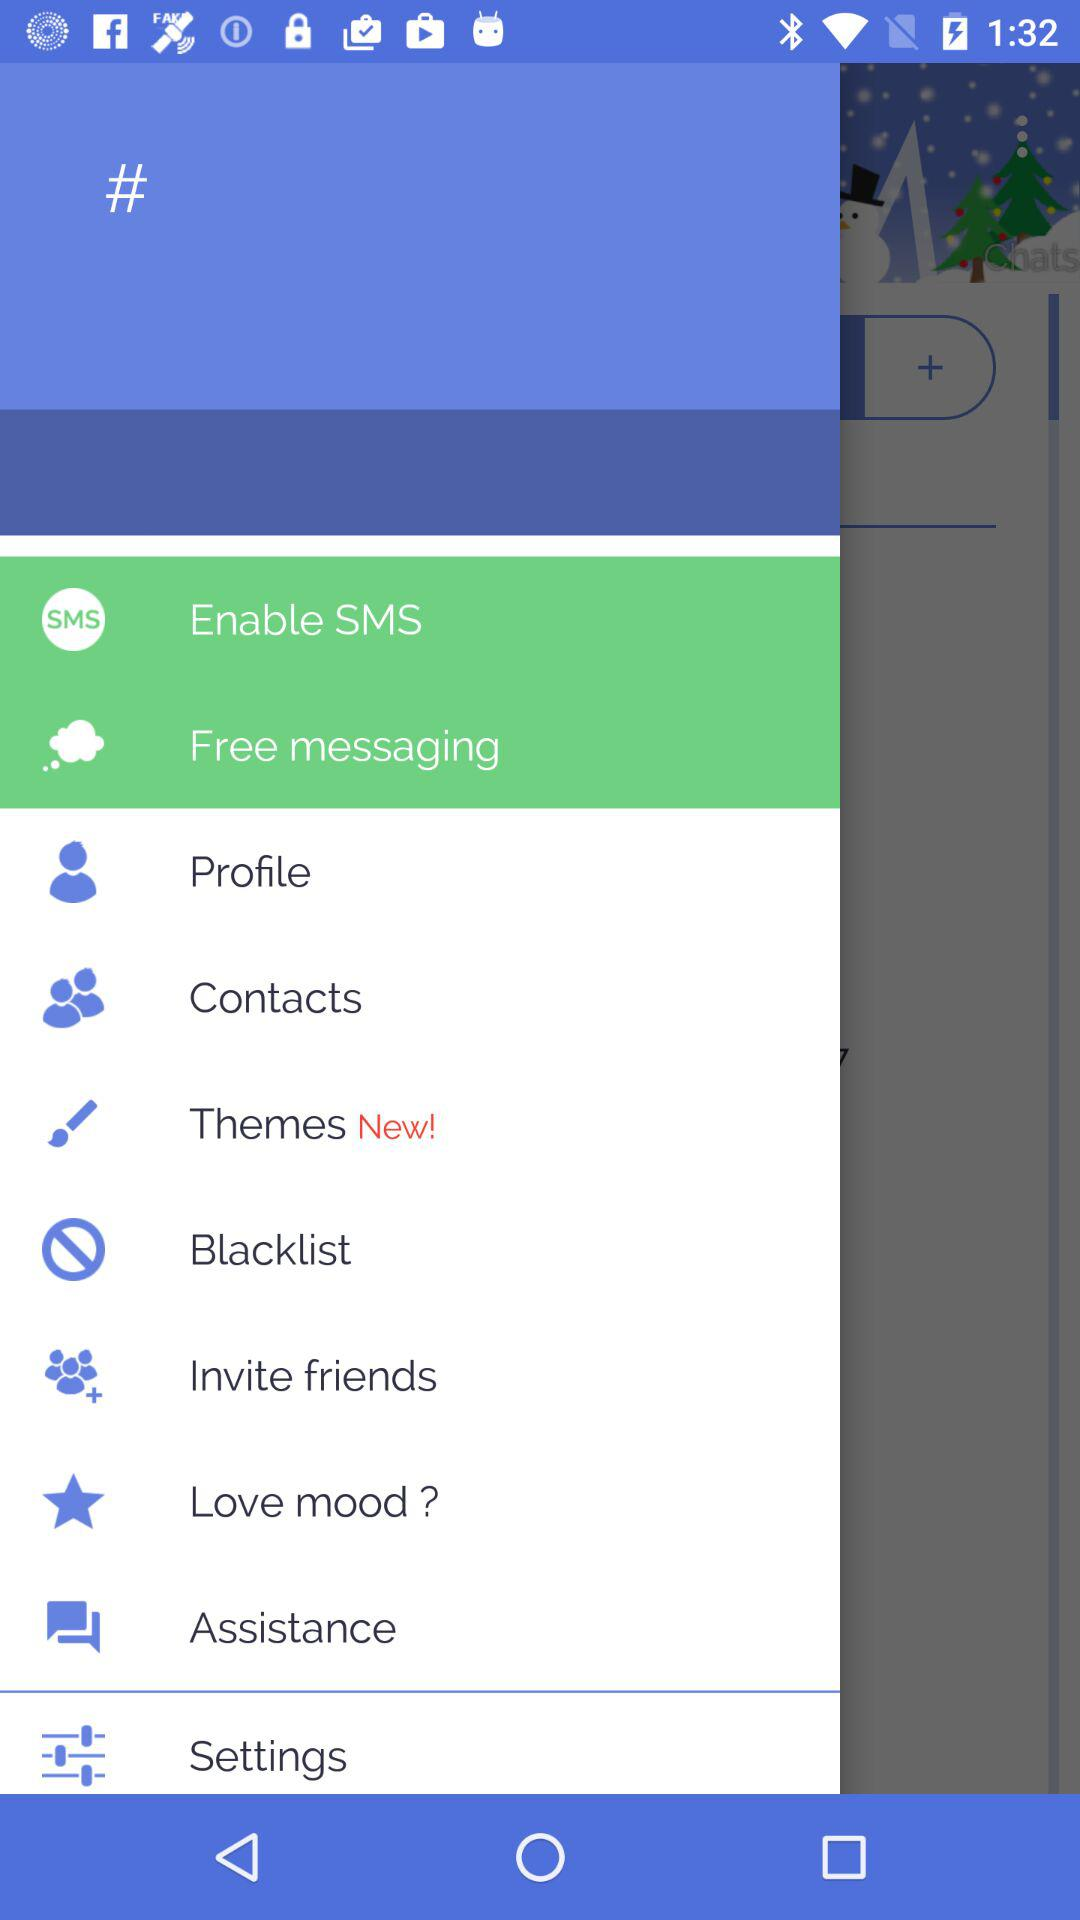How many items have the text 'New'?
Answer the question using a single word or phrase. 1 